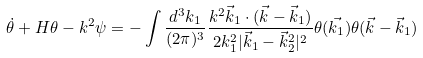Convert formula to latex. <formula><loc_0><loc_0><loc_500><loc_500>\dot { \theta } + H \theta - k ^ { 2 } \psi = - \int \frac { d ^ { 3 } k _ { 1 } } { ( 2 \pi ) ^ { 3 } } \frac { k ^ { 2 } { \vec { k } _ { 1 } } \cdot ( \vec { k } - \vec { k } _ { 1 } ) } { 2 k _ { 1 } ^ { 2 } | { \vec { k } _ { 1 } } - { \vec { k } _ { 2 } ^ { 2 } } | ^ { 2 } } \theta ( \vec { k _ { 1 } } ) \theta ( { \vec { k } } - { \vec { k } _ { 1 } } )</formula> 